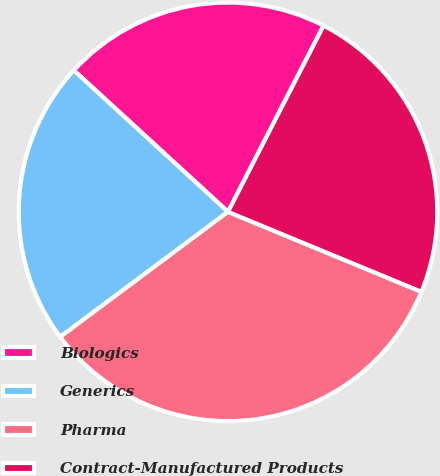<chart> <loc_0><loc_0><loc_500><loc_500><pie_chart><fcel>Biologics<fcel>Generics<fcel>Pharma<fcel>Contract-Manufactured Products<nl><fcel>20.73%<fcel>22.01%<fcel>33.56%<fcel>23.69%<nl></chart> 